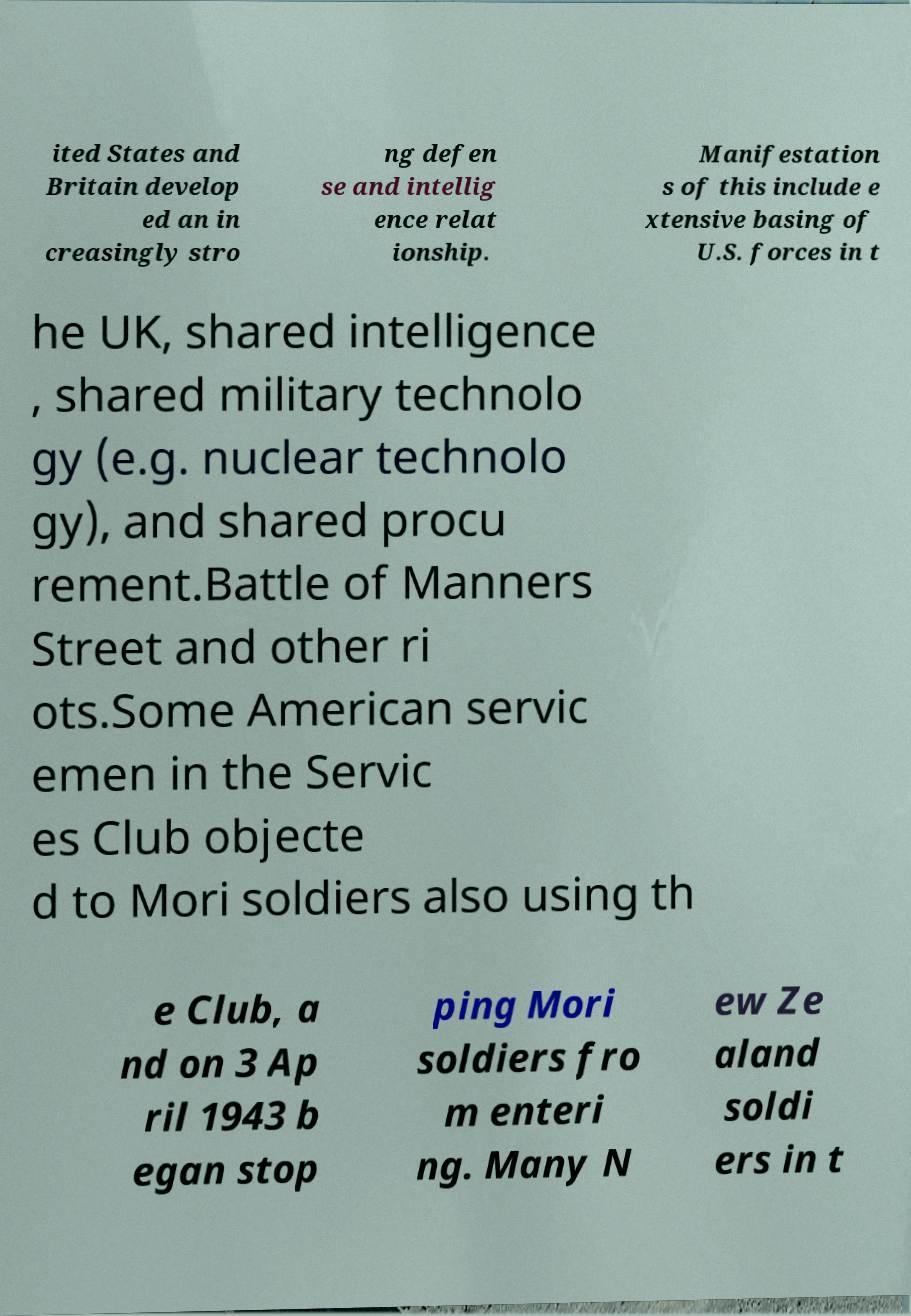There's text embedded in this image that I need extracted. Can you transcribe it verbatim? ited States and Britain develop ed an in creasingly stro ng defen se and intellig ence relat ionship. Manifestation s of this include e xtensive basing of U.S. forces in t he UK, shared intelligence , shared military technolo gy (e.g. nuclear technolo gy), and shared procu rement.Battle of Manners Street and other ri ots.Some American servic emen in the Servic es Club objecte d to Mori soldiers also using th e Club, a nd on 3 Ap ril 1943 b egan stop ping Mori soldiers fro m enteri ng. Many N ew Ze aland soldi ers in t 